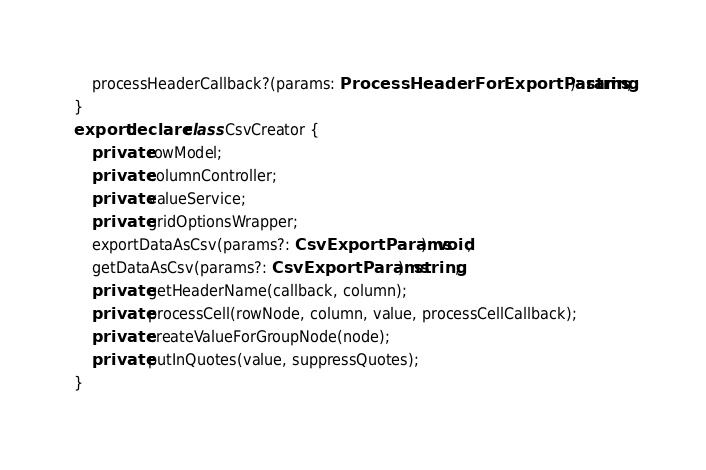Convert code to text. <code><loc_0><loc_0><loc_500><loc_500><_TypeScript_>    processHeaderCallback?(params: ProcessHeaderForExportParams): string;
}
export declare class CsvCreator {
    private rowModel;
    private columnController;
    private valueService;
    private gridOptionsWrapper;
    exportDataAsCsv(params?: CsvExportParams): void;
    getDataAsCsv(params?: CsvExportParams): string;
    private getHeaderName(callback, column);
    private processCell(rowNode, column, value, processCellCallback);
    private createValueForGroupNode(node);
    private putInQuotes(value, suppressQuotes);
}
</code> 